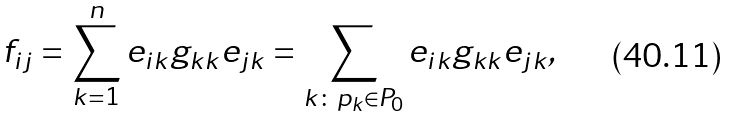Convert formula to latex. <formula><loc_0><loc_0><loc_500><loc_500>f _ { i j } & = \sum _ { k = 1 } ^ { n } e _ { i k } g _ { k k } e _ { j k } = \sum _ { k \colon p _ { k } \in P _ { 0 } } e _ { i k } g _ { k k } e _ { j k } ,</formula> 